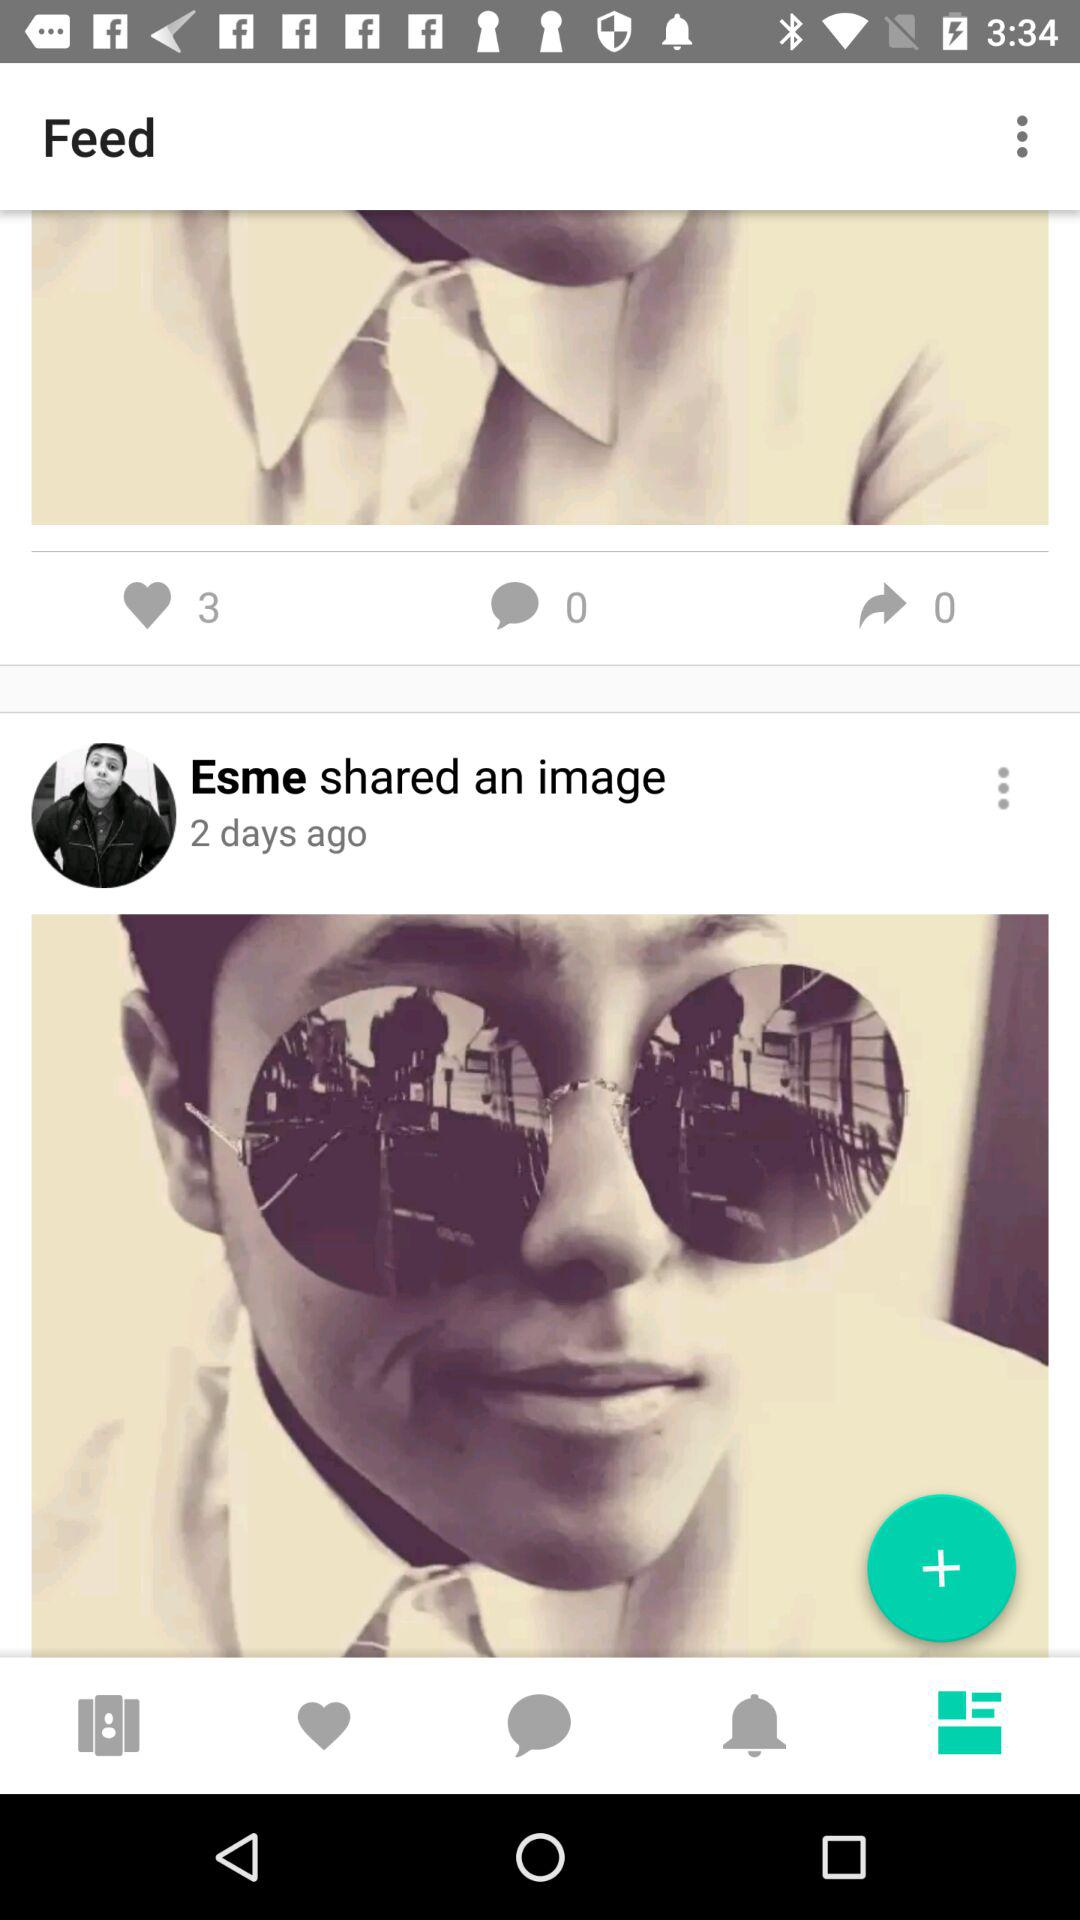What is the number of likes shown on the screen? The number of likes shown on the screen is 3. 